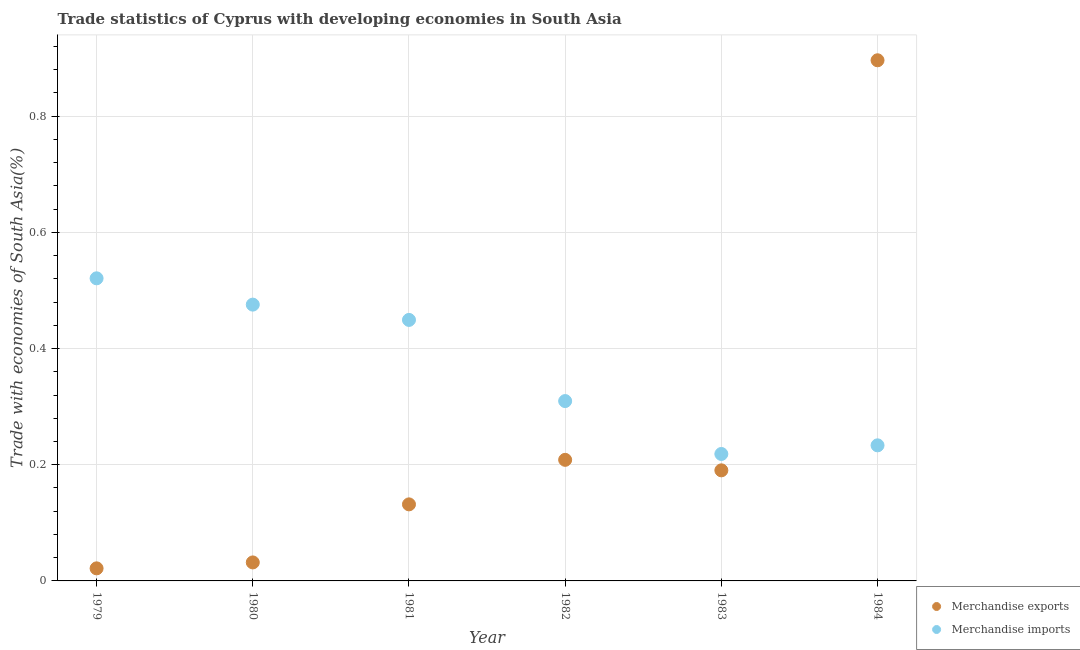Is the number of dotlines equal to the number of legend labels?
Your response must be concise. Yes. What is the merchandise imports in 1982?
Offer a terse response. 0.31. Across all years, what is the maximum merchandise imports?
Provide a succinct answer. 0.52. Across all years, what is the minimum merchandise exports?
Your answer should be very brief. 0.02. In which year was the merchandise exports maximum?
Provide a short and direct response. 1984. In which year was the merchandise imports minimum?
Your response must be concise. 1983. What is the total merchandise imports in the graph?
Your response must be concise. 2.21. What is the difference between the merchandise imports in 1981 and that in 1983?
Make the answer very short. 0.23. What is the difference between the merchandise exports in 1982 and the merchandise imports in 1979?
Your answer should be compact. -0.31. What is the average merchandise imports per year?
Offer a very short reply. 0.37. In the year 1982, what is the difference between the merchandise imports and merchandise exports?
Your response must be concise. 0.1. What is the ratio of the merchandise exports in 1979 to that in 1981?
Your answer should be compact. 0.16. Is the difference between the merchandise exports in 1979 and 1981 greater than the difference between the merchandise imports in 1979 and 1981?
Your answer should be very brief. No. What is the difference between the highest and the second highest merchandise imports?
Provide a succinct answer. 0.05. What is the difference between the highest and the lowest merchandise imports?
Ensure brevity in your answer.  0.3. Is the sum of the merchandise imports in 1979 and 1984 greater than the maximum merchandise exports across all years?
Offer a very short reply. No. What is the difference between two consecutive major ticks on the Y-axis?
Offer a terse response. 0.2. How many legend labels are there?
Your answer should be very brief. 2. What is the title of the graph?
Provide a short and direct response. Trade statistics of Cyprus with developing economies in South Asia. Does "GDP per capita" appear as one of the legend labels in the graph?
Provide a short and direct response. No. What is the label or title of the X-axis?
Your answer should be very brief. Year. What is the label or title of the Y-axis?
Your answer should be very brief. Trade with economies of South Asia(%). What is the Trade with economies of South Asia(%) of Merchandise exports in 1979?
Your answer should be compact. 0.02. What is the Trade with economies of South Asia(%) of Merchandise imports in 1979?
Give a very brief answer. 0.52. What is the Trade with economies of South Asia(%) of Merchandise exports in 1980?
Provide a succinct answer. 0.03. What is the Trade with economies of South Asia(%) of Merchandise imports in 1980?
Ensure brevity in your answer.  0.48. What is the Trade with economies of South Asia(%) in Merchandise exports in 1981?
Your answer should be very brief. 0.13. What is the Trade with economies of South Asia(%) in Merchandise imports in 1981?
Provide a short and direct response. 0.45. What is the Trade with economies of South Asia(%) in Merchandise exports in 1982?
Give a very brief answer. 0.21. What is the Trade with economies of South Asia(%) in Merchandise imports in 1982?
Keep it short and to the point. 0.31. What is the Trade with economies of South Asia(%) of Merchandise exports in 1983?
Your response must be concise. 0.19. What is the Trade with economies of South Asia(%) of Merchandise imports in 1983?
Keep it short and to the point. 0.22. What is the Trade with economies of South Asia(%) of Merchandise exports in 1984?
Ensure brevity in your answer.  0.9. What is the Trade with economies of South Asia(%) of Merchandise imports in 1984?
Offer a very short reply. 0.23. Across all years, what is the maximum Trade with economies of South Asia(%) of Merchandise exports?
Your response must be concise. 0.9. Across all years, what is the maximum Trade with economies of South Asia(%) of Merchandise imports?
Provide a succinct answer. 0.52. Across all years, what is the minimum Trade with economies of South Asia(%) of Merchandise exports?
Your answer should be very brief. 0.02. Across all years, what is the minimum Trade with economies of South Asia(%) of Merchandise imports?
Your answer should be very brief. 0.22. What is the total Trade with economies of South Asia(%) in Merchandise exports in the graph?
Ensure brevity in your answer.  1.48. What is the total Trade with economies of South Asia(%) in Merchandise imports in the graph?
Offer a terse response. 2.21. What is the difference between the Trade with economies of South Asia(%) in Merchandise exports in 1979 and that in 1980?
Offer a very short reply. -0.01. What is the difference between the Trade with economies of South Asia(%) of Merchandise imports in 1979 and that in 1980?
Your answer should be compact. 0.05. What is the difference between the Trade with economies of South Asia(%) of Merchandise exports in 1979 and that in 1981?
Give a very brief answer. -0.11. What is the difference between the Trade with economies of South Asia(%) in Merchandise imports in 1979 and that in 1981?
Your answer should be compact. 0.07. What is the difference between the Trade with economies of South Asia(%) in Merchandise exports in 1979 and that in 1982?
Ensure brevity in your answer.  -0.19. What is the difference between the Trade with economies of South Asia(%) of Merchandise imports in 1979 and that in 1982?
Provide a succinct answer. 0.21. What is the difference between the Trade with economies of South Asia(%) in Merchandise exports in 1979 and that in 1983?
Your response must be concise. -0.17. What is the difference between the Trade with economies of South Asia(%) of Merchandise imports in 1979 and that in 1983?
Your answer should be very brief. 0.3. What is the difference between the Trade with economies of South Asia(%) of Merchandise exports in 1979 and that in 1984?
Keep it short and to the point. -0.87. What is the difference between the Trade with economies of South Asia(%) of Merchandise imports in 1979 and that in 1984?
Keep it short and to the point. 0.29. What is the difference between the Trade with economies of South Asia(%) of Merchandise exports in 1980 and that in 1981?
Ensure brevity in your answer.  -0.1. What is the difference between the Trade with economies of South Asia(%) in Merchandise imports in 1980 and that in 1981?
Provide a short and direct response. 0.03. What is the difference between the Trade with economies of South Asia(%) of Merchandise exports in 1980 and that in 1982?
Give a very brief answer. -0.18. What is the difference between the Trade with economies of South Asia(%) in Merchandise imports in 1980 and that in 1982?
Offer a very short reply. 0.17. What is the difference between the Trade with economies of South Asia(%) of Merchandise exports in 1980 and that in 1983?
Your answer should be compact. -0.16. What is the difference between the Trade with economies of South Asia(%) in Merchandise imports in 1980 and that in 1983?
Your response must be concise. 0.26. What is the difference between the Trade with economies of South Asia(%) in Merchandise exports in 1980 and that in 1984?
Ensure brevity in your answer.  -0.86. What is the difference between the Trade with economies of South Asia(%) in Merchandise imports in 1980 and that in 1984?
Provide a short and direct response. 0.24. What is the difference between the Trade with economies of South Asia(%) in Merchandise exports in 1981 and that in 1982?
Offer a terse response. -0.08. What is the difference between the Trade with economies of South Asia(%) in Merchandise imports in 1981 and that in 1982?
Give a very brief answer. 0.14. What is the difference between the Trade with economies of South Asia(%) of Merchandise exports in 1981 and that in 1983?
Your response must be concise. -0.06. What is the difference between the Trade with economies of South Asia(%) in Merchandise imports in 1981 and that in 1983?
Ensure brevity in your answer.  0.23. What is the difference between the Trade with economies of South Asia(%) of Merchandise exports in 1981 and that in 1984?
Your response must be concise. -0.76. What is the difference between the Trade with economies of South Asia(%) of Merchandise imports in 1981 and that in 1984?
Keep it short and to the point. 0.22. What is the difference between the Trade with economies of South Asia(%) in Merchandise exports in 1982 and that in 1983?
Offer a terse response. 0.02. What is the difference between the Trade with economies of South Asia(%) of Merchandise imports in 1982 and that in 1983?
Provide a succinct answer. 0.09. What is the difference between the Trade with economies of South Asia(%) of Merchandise exports in 1982 and that in 1984?
Ensure brevity in your answer.  -0.69. What is the difference between the Trade with economies of South Asia(%) of Merchandise imports in 1982 and that in 1984?
Provide a short and direct response. 0.08. What is the difference between the Trade with economies of South Asia(%) of Merchandise exports in 1983 and that in 1984?
Give a very brief answer. -0.71. What is the difference between the Trade with economies of South Asia(%) in Merchandise imports in 1983 and that in 1984?
Provide a short and direct response. -0.01. What is the difference between the Trade with economies of South Asia(%) in Merchandise exports in 1979 and the Trade with economies of South Asia(%) in Merchandise imports in 1980?
Offer a very short reply. -0.45. What is the difference between the Trade with economies of South Asia(%) of Merchandise exports in 1979 and the Trade with economies of South Asia(%) of Merchandise imports in 1981?
Keep it short and to the point. -0.43. What is the difference between the Trade with economies of South Asia(%) in Merchandise exports in 1979 and the Trade with economies of South Asia(%) in Merchandise imports in 1982?
Offer a terse response. -0.29. What is the difference between the Trade with economies of South Asia(%) in Merchandise exports in 1979 and the Trade with economies of South Asia(%) in Merchandise imports in 1983?
Your response must be concise. -0.2. What is the difference between the Trade with economies of South Asia(%) in Merchandise exports in 1979 and the Trade with economies of South Asia(%) in Merchandise imports in 1984?
Make the answer very short. -0.21. What is the difference between the Trade with economies of South Asia(%) in Merchandise exports in 1980 and the Trade with economies of South Asia(%) in Merchandise imports in 1981?
Keep it short and to the point. -0.42. What is the difference between the Trade with economies of South Asia(%) in Merchandise exports in 1980 and the Trade with economies of South Asia(%) in Merchandise imports in 1982?
Your answer should be compact. -0.28. What is the difference between the Trade with economies of South Asia(%) in Merchandise exports in 1980 and the Trade with economies of South Asia(%) in Merchandise imports in 1983?
Provide a succinct answer. -0.19. What is the difference between the Trade with economies of South Asia(%) of Merchandise exports in 1980 and the Trade with economies of South Asia(%) of Merchandise imports in 1984?
Your answer should be compact. -0.2. What is the difference between the Trade with economies of South Asia(%) in Merchandise exports in 1981 and the Trade with economies of South Asia(%) in Merchandise imports in 1982?
Give a very brief answer. -0.18. What is the difference between the Trade with economies of South Asia(%) of Merchandise exports in 1981 and the Trade with economies of South Asia(%) of Merchandise imports in 1983?
Your answer should be compact. -0.09. What is the difference between the Trade with economies of South Asia(%) of Merchandise exports in 1981 and the Trade with economies of South Asia(%) of Merchandise imports in 1984?
Give a very brief answer. -0.1. What is the difference between the Trade with economies of South Asia(%) of Merchandise exports in 1982 and the Trade with economies of South Asia(%) of Merchandise imports in 1983?
Your answer should be compact. -0.01. What is the difference between the Trade with economies of South Asia(%) of Merchandise exports in 1982 and the Trade with economies of South Asia(%) of Merchandise imports in 1984?
Offer a terse response. -0.03. What is the difference between the Trade with economies of South Asia(%) in Merchandise exports in 1983 and the Trade with economies of South Asia(%) in Merchandise imports in 1984?
Offer a terse response. -0.04. What is the average Trade with economies of South Asia(%) of Merchandise exports per year?
Make the answer very short. 0.25. What is the average Trade with economies of South Asia(%) in Merchandise imports per year?
Your answer should be compact. 0.37. In the year 1979, what is the difference between the Trade with economies of South Asia(%) of Merchandise exports and Trade with economies of South Asia(%) of Merchandise imports?
Your answer should be very brief. -0.5. In the year 1980, what is the difference between the Trade with economies of South Asia(%) of Merchandise exports and Trade with economies of South Asia(%) of Merchandise imports?
Make the answer very short. -0.44. In the year 1981, what is the difference between the Trade with economies of South Asia(%) of Merchandise exports and Trade with economies of South Asia(%) of Merchandise imports?
Offer a very short reply. -0.32. In the year 1982, what is the difference between the Trade with economies of South Asia(%) of Merchandise exports and Trade with economies of South Asia(%) of Merchandise imports?
Ensure brevity in your answer.  -0.1. In the year 1983, what is the difference between the Trade with economies of South Asia(%) of Merchandise exports and Trade with economies of South Asia(%) of Merchandise imports?
Keep it short and to the point. -0.03. In the year 1984, what is the difference between the Trade with economies of South Asia(%) of Merchandise exports and Trade with economies of South Asia(%) of Merchandise imports?
Provide a short and direct response. 0.66. What is the ratio of the Trade with economies of South Asia(%) of Merchandise exports in 1979 to that in 1980?
Make the answer very short. 0.68. What is the ratio of the Trade with economies of South Asia(%) in Merchandise imports in 1979 to that in 1980?
Keep it short and to the point. 1.1. What is the ratio of the Trade with economies of South Asia(%) of Merchandise exports in 1979 to that in 1981?
Offer a terse response. 0.16. What is the ratio of the Trade with economies of South Asia(%) of Merchandise imports in 1979 to that in 1981?
Keep it short and to the point. 1.16. What is the ratio of the Trade with economies of South Asia(%) of Merchandise exports in 1979 to that in 1982?
Make the answer very short. 0.1. What is the ratio of the Trade with economies of South Asia(%) of Merchandise imports in 1979 to that in 1982?
Your answer should be compact. 1.68. What is the ratio of the Trade with economies of South Asia(%) of Merchandise exports in 1979 to that in 1983?
Keep it short and to the point. 0.11. What is the ratio of the Trade with economies of South Asia(%) in Merchandise imports in 1979 to that in 1983?
Make the answer very short. 2.38. What is the ratio of the Trade with economies of South Asia(%) in Merchandise exports in 1979 to that in 1984?
Your answer should be very brief. 0.02. What is the ratio of the Trade with economies of South Asia(%) of Merchandise imports in 1979 to that in 1984?
Your answer should be compact. 2.23. What is the ratio of the Trade with economies of South Asia(%) of Merchandise exports in 1980 to that in 1981?
Your answer should be very brief. 0.24. What is the ratio of the Trade with economies of South Asia(%) in Merchandise imports in 1980 to that in 1981?
Provide a short and direct response. 1.06. What is the ratio of the Trade with economies of South Asia(%) in Merchandise exports in 1980 to that in 1982?
Offer a terse response. 0.15. What is the ratio of the Trade with economies of South Asia(%) in Merchandise imports in 1980 to that in 1982?
Your response must be concise. 1.54. What is the ratio of the Trade with economies of South Asia(%) in Merchandise exports in 1980 to that in 1983?
Your answer should be compact. 0.17. What is the ratio of the Trade with economies of South Asia(%) of Merchandise imports in 1980 to that in 1983?
Make the answer very short. 2.18. What is the ratio of the Trade with economies of South Asia(%) in Merchandise exports in 1980 to that in 1984?
Your answer should be very brief. 0.04. What is the ratio of the Trade with economies of South Asia(%) of Merchandise imports in 1980 to that in 1984?
Offer a terse response. 2.04. What is the ratio of the Trade with economies of South Asia(%) of Merchandise exports in 1981 to that in 1982?
Offer a terse response. 0.63. What is the ratio of the Trade with economies of South Asia(%) in Merchandise imports in 1981 to that in 1982?
Offer a terse response. 1.45. What is the ratio of the Trade with economies of South Asia(%) in Merchandise exports in 1981 to that in 1983?
Your answer should be very brief. 0.69. What is the ratio of the Trade with economies of South Asia(%) in Merchandise imports in 1981 to that in 1983?
Provide a succinct answer. 2.06. What is the ratio of the Trade with economies of South Asia(%) of Merchandise exports in 1981 to that in 1984?
Your answer should be very brief. 0.15. What is the ratio of the Trade with economies of South Asia(%) of Merchandise imports in 1981 to that in 1984?
Your answer should be very brief. 1.93. What is the ratio of the Trade with economies of South Asia(%) of Merchandise exports in 1982 to that in 1983?
Offer a very short reply. 1.09. What is the ratio of the Trade with economies of South Asia(%) in Merchandise imports in 1982 to that in 1983?
Your response must be concise. 1.42. What is the ratio of the Trade with economies of South Asia(%) of Merchandise exports in 1982 to that in 1984?
Keep it short and to the point. 0.23. What is the ratio of the Trade with economies of South Asia(%) of Merchandise imports in 1982 to that in 1984?
Your answer should be very brief. 1.33. What is the ratio of the Trade with economies of South Asia(%) in Merchandise exports in 1983 to that in 1984?
Offer a terse response. 0.21. What is the ratio of the Trade with economies of South Asia(%) of Merchandise imports in 1983 to that in 1984?
Offer a very short reply. 0.94. What is the difference between the highest and the second highest Trade with economies of South Asia(%) in Merchandise exports?
Provide a short and direct response. 0.69. What is the difference between the highest and the second highest Trade with economies of South Asia(%) in Merchandise imports?
Make the answer very short. 0.05. What is the difference between the highest and the lowest Trade with economies of South Asia(%) of Merchandise exports?
Keep it short and to the point. 0.87. What is the difference between the highest and the lowest Trade with economies of South Asia(%) of Merchandise imports?
Provide a short and direct response. 0.3. 